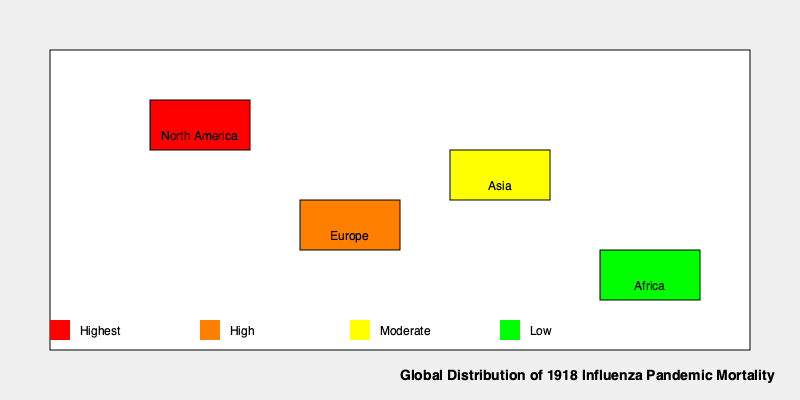Based on the global distribution map of the 1918 influenza pandemic mortality rates, which continent experienced the highest mortality rate, and what factors might have contributed to this outcome? To answer this question, we need to analyze the map and consider historical context:

1. Examine the color-coded map:
   - Red indicates the highest mortality rate
   - Orange indicates high mortality rate
   - Yellow indicates moderate mortality rate
   - Green indicates low mortality rate

2. Identify the continent with the red coloration:
   - North America is colored red, indicating the highest mortality rate

3. Consider factors that might have contributed to North America's high mortality rate:
   a) Population density: Urban areas in North America were rapidly growing, facilitating disease spread
   b) World War I: Troop movements and crowded military camps accelerated transmission
   c) Healthcare infrastructure: Despite advancements, it was overwhelmed by the pandemic's scale
   d) Lack of understanding: The viral nature of influenza was not yet known, hampering effective responses
   e) Multiple waves: North America experienced several waves of the pandemic, potentially increasing overall mortality
   f) Reporting accuracy: North America may have had more accurate mortality reporting compared to other regions

4. Compare to other continents:
   - Europe (orange): High mortality, but slightly lower than North America, possibly due to pre-existing immunity from earlier waves
   - Asia (yellow): Moderate mortality, potentially due to less accurate reporting or different population structures
   - Africa (green): Lower reported mortality, possibly due to limited data collection or different population demographics

5. Consider the limitations of historical data:
   - Mortality rates may be influenced by reporting accuracy and completeness, which varied globally

In conclusion, North America experienced the highest mortality rate during the 1918 influenza pandemic, likely due to a combination of population density, wartime conditions, healthcare limitations, and potentially more accurate reporting.
Answer: North America; factors include population density, World War I troop movements, overwhelmed healthcare, lack of viral knowledge, multiple pandemic waves, and potentially more accurate reporting. 